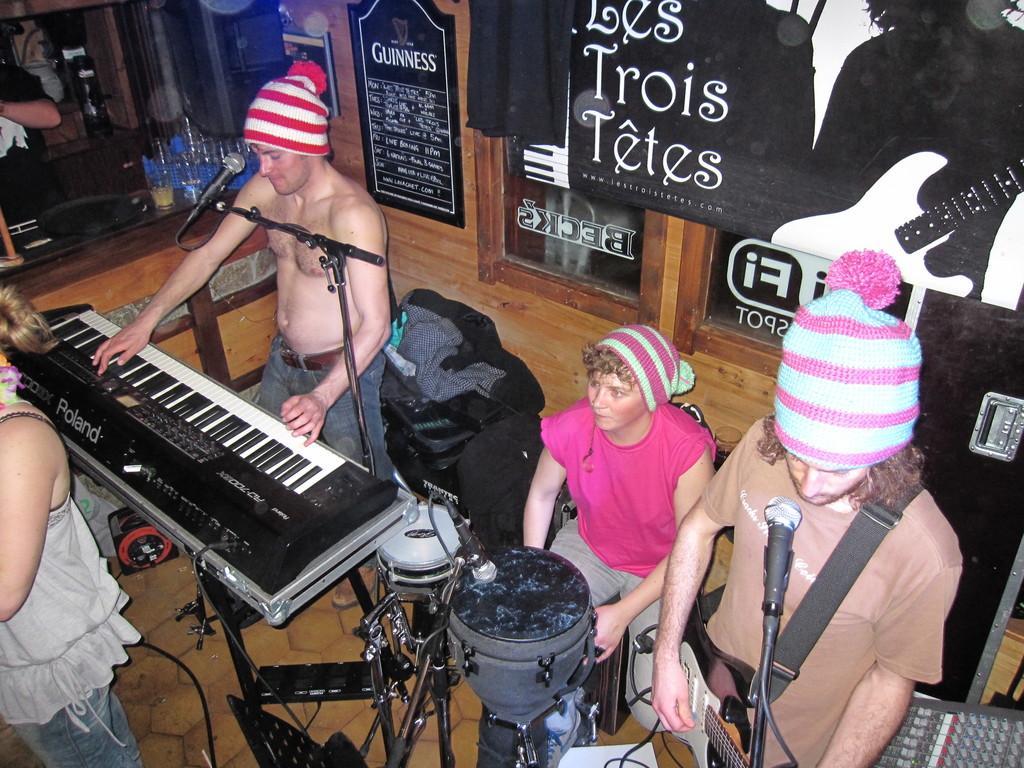How would you summarize this image in a sentence or two? In this image there are group of persons who are playing musical instruments and at the background of the image there is a door and black color sheet. 